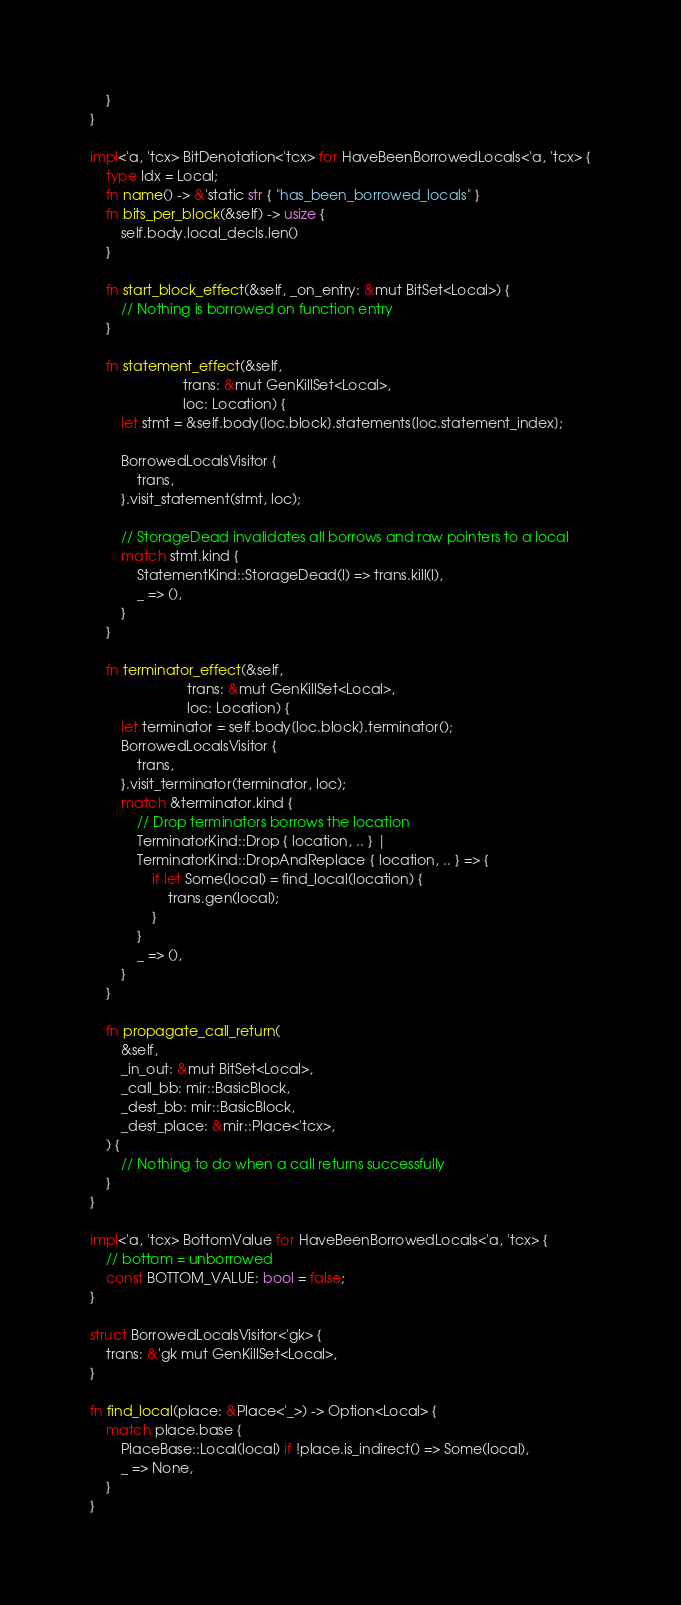Convert code to text. <code><loc_0><loc_0><loc_500><loc_500><_Rust_>    }
}

impl<'a, 'tcx> BitDenotation<'tcx> for HaveBeenBorrowedLocals<'a, 'tcx> {
    type Idx = Local;
    fn name() -> &'static str { "has_been_borrowed_locals" }
    fn bits_per_block(&self) -> usize {
        self.body.local_decls.len()
    }

    fn start_block_effect(&self, _on_entry: &mut BitSet<Local>) {
        // Nothing is borrowed on function entry
    }

    fn statement_effect(&self,
                        trans: &mut GenKillSet<Local>,
                        loc: Location) {
        let stmt = &self.body[loc.block].statements[loc.statement_index];

        BorrowedLocalsVisitor {
            trans,
        }.visit_statement(stmt, loc);

        // StorageDead invalidates all borrows and raw pointers to a local
        match stmt.kind {
            StatementKind::StorageDead(l) => trans.kill(l),
            _ => (),
        }
    }

    fn terminator_effect(&self,
                         trans: &mut GenKillSet<Local>,
                         loc: Location) {
        let terminator = self.body[loc.block].terminator();
        BorrowedLocalsVisitor {
            trans,
        }.visit_terminator(terminator, loc);
        match &terminator.kind {
            // Drop terminators borrows the location
            TerminatorKind::Drop { location, .. } |
            TerminatorKind::DropAndReplace { location, .. } => {
                if let Some(local) = find_local(location) {
                    trans.gen(local);
                }
            }
            _ => (),
        }
    }

    fn propagate_call_return(
        &self,
        _in_out: &mut BitSet<Local>,
        _call_bb: mir::BasicBlock,
        _dest_bb: mir::BasicBlock,
        _dest_place: &mir::Place<'tcx>,
    ) {
        // Nothing to do when a call returns successfully
    }
}

impl<'a, 'tcx> BottomValue for HaveBeenBorrowedLocals<'a, 'tcx> {
    // bottom = unborrowed
    const BOTTOM_VALUE: bool = false;
}

struct BorrowedLocalsVisitor<'gk> {
    trans: &'gk mut GenKillSet<Local>,
}

fn find_local(place: &Place<'_>) -> Option<Local> {
    match place.base {
        PlaceBase::Local(local) if !place.is_indirect() => Some(local),
        _ => None,
    }
}
</code> 